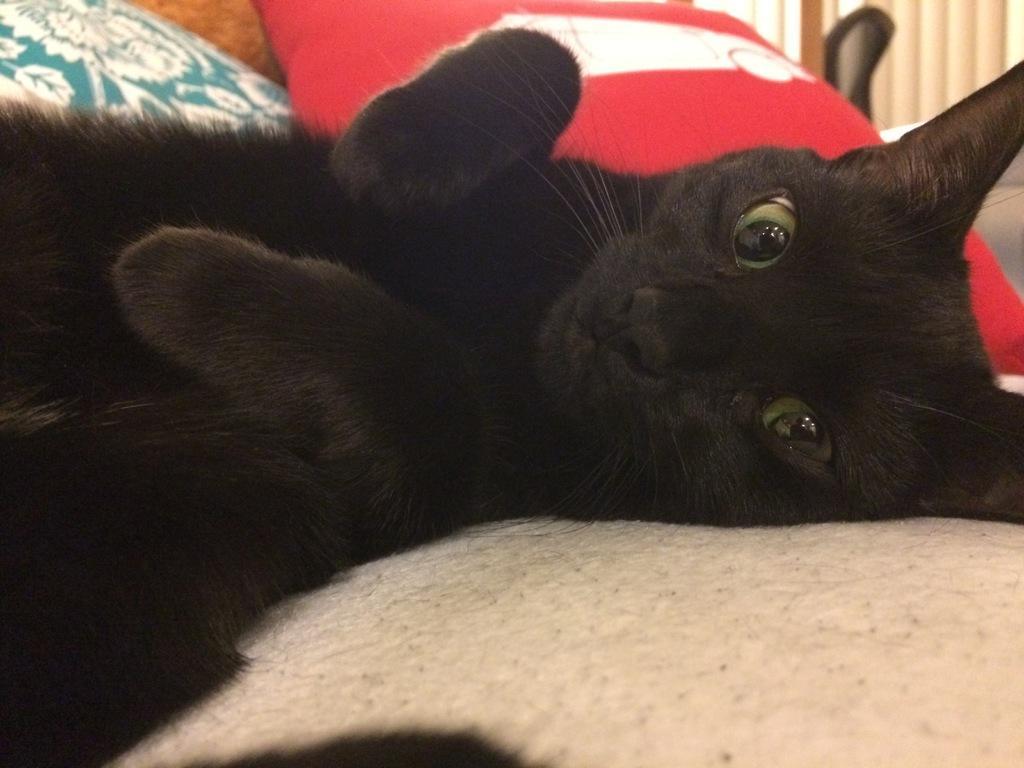Describe this image in one or two sentences. In this picture I can see a cat which is of black color and it is on the white color surface. In the background I see a cushion which is of red and white color and on the top left of this image I see the designs on the blue color thing. 